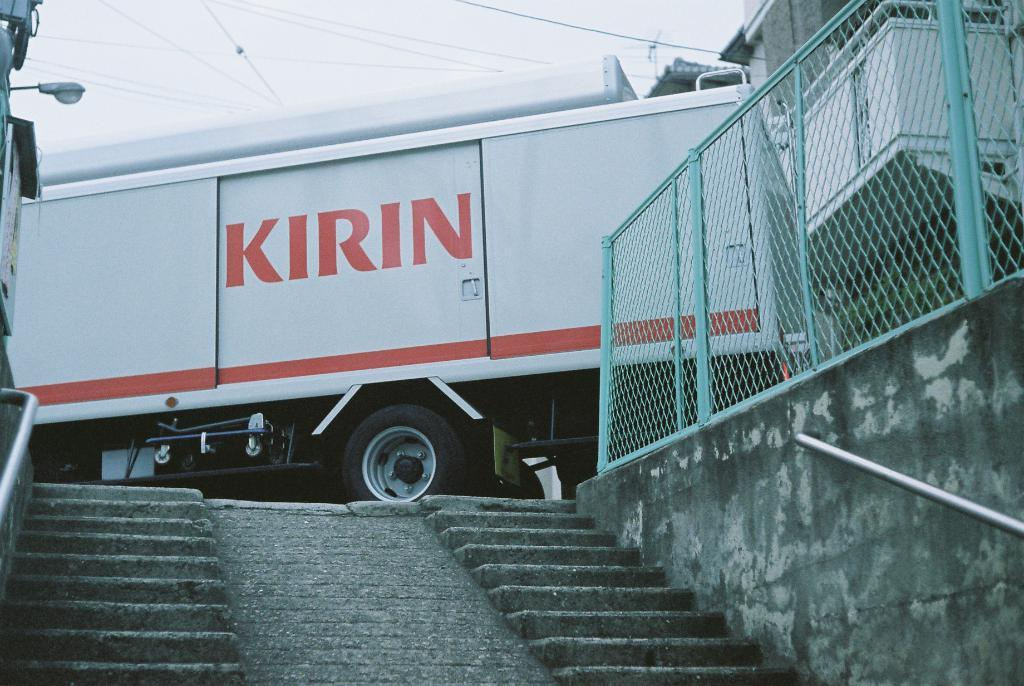What is on the road in the image? There is a vehicle on the road in the image. What else can be seen in the image besides the vehicle? Electric cables, buildings, steps, a fence, a street light, and the sky are visible in the image. Can you describe the type of infrastructure present in the image? There are electric cables, a fence, and a street light, which are all part of the infrastructure. What is the purpose of the steps in the image? The steps might be used for accessing a higher level or as a part of a building's design. What type of cracker is being used to prop up the street light in the image? There is no cracker present in the image, and the street light is not being propped up by any object. 